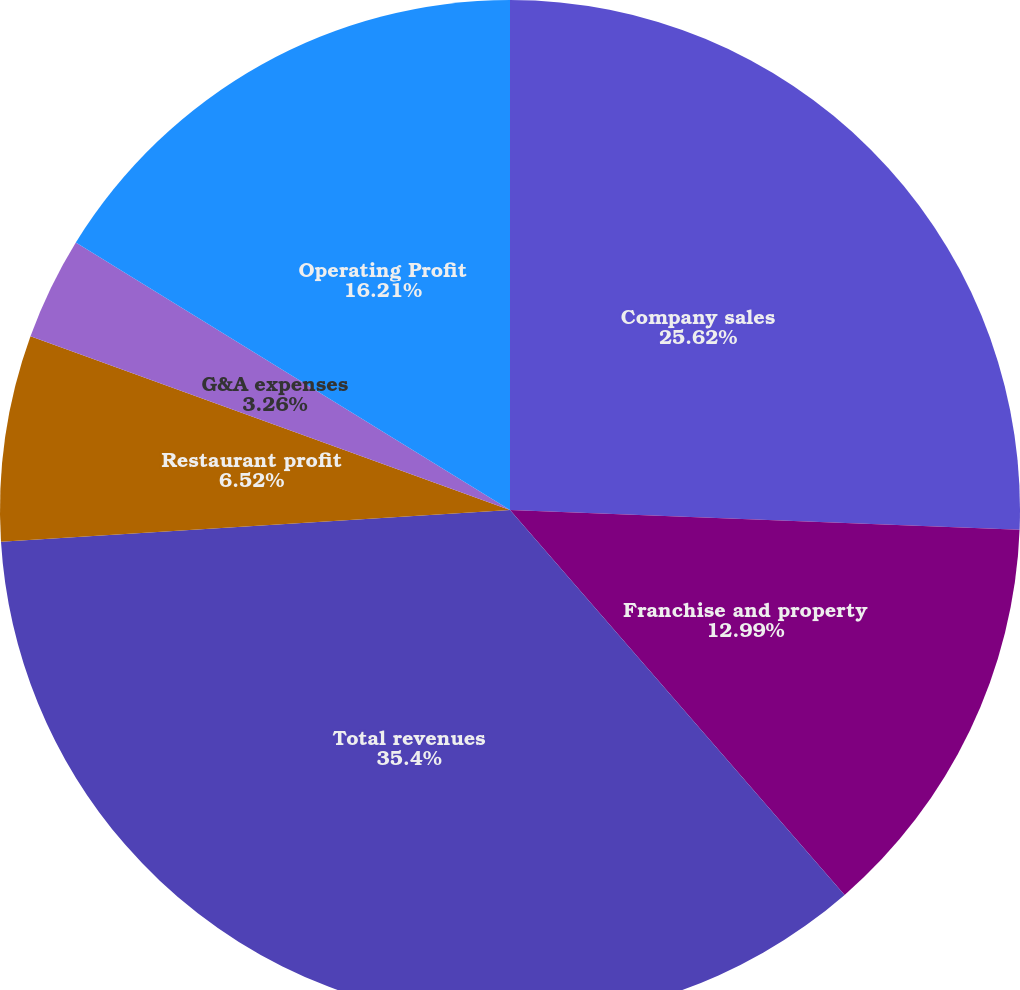Convert chart to OTSL. <chart><loc_0><loc_0><loc_500><loc_500><pie_chart><fcel>Company sales<fcel>Franchise and property<fcel>Total revenues<fcel>Restaurant profit<fcel>G&A expenses<fcel>Operating Profit<nl><fcel>25.62%<fcel>12.99%<fcel>35.4%<fcel>6.52%<fcel>3.26%<fcel>16.21%<nl></chart> 